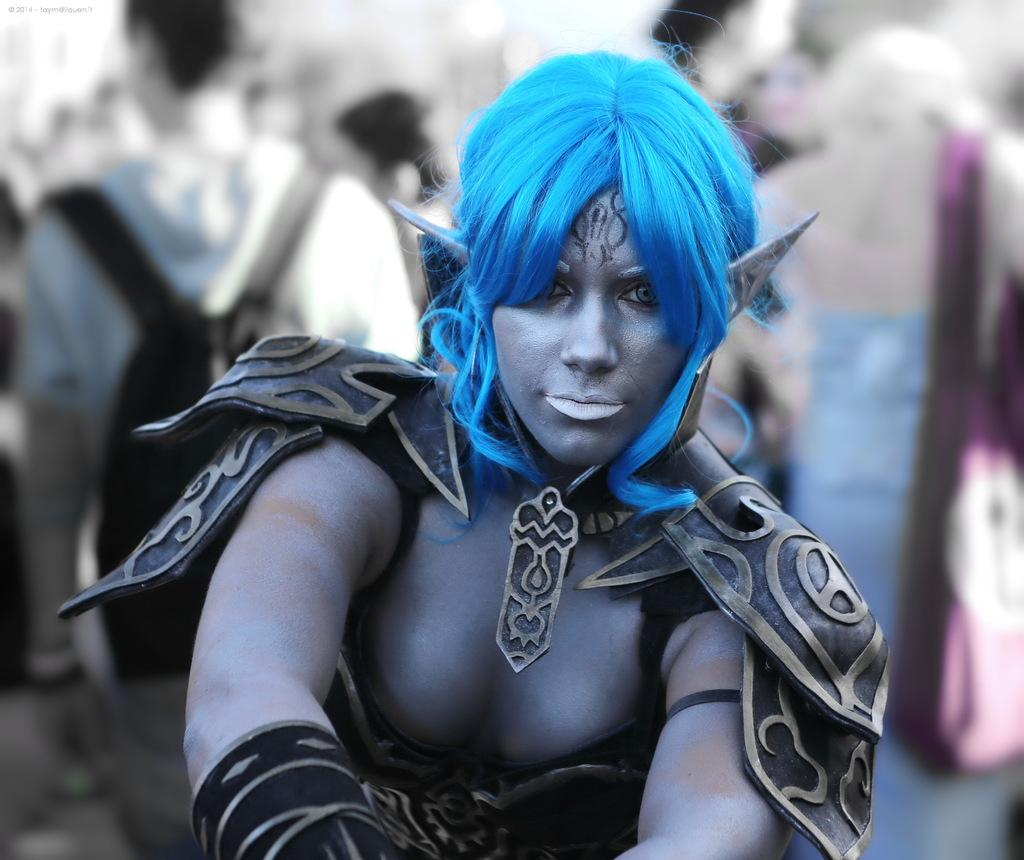What is the woman in the image doing? The woman is standing in the image. What is the woman wearing? The woman is wearing a costume. Are there any other people in the image? Yes, there are people standing behind her. What are the people behind the woman wearing? The people are wearing bags. Can you describe the background of the image? The background of the image is blurry. Can you see a tent in the image? There is no tent present in the image. What type of rod is being used by the woman in the image? There is no rod visible in the image. 